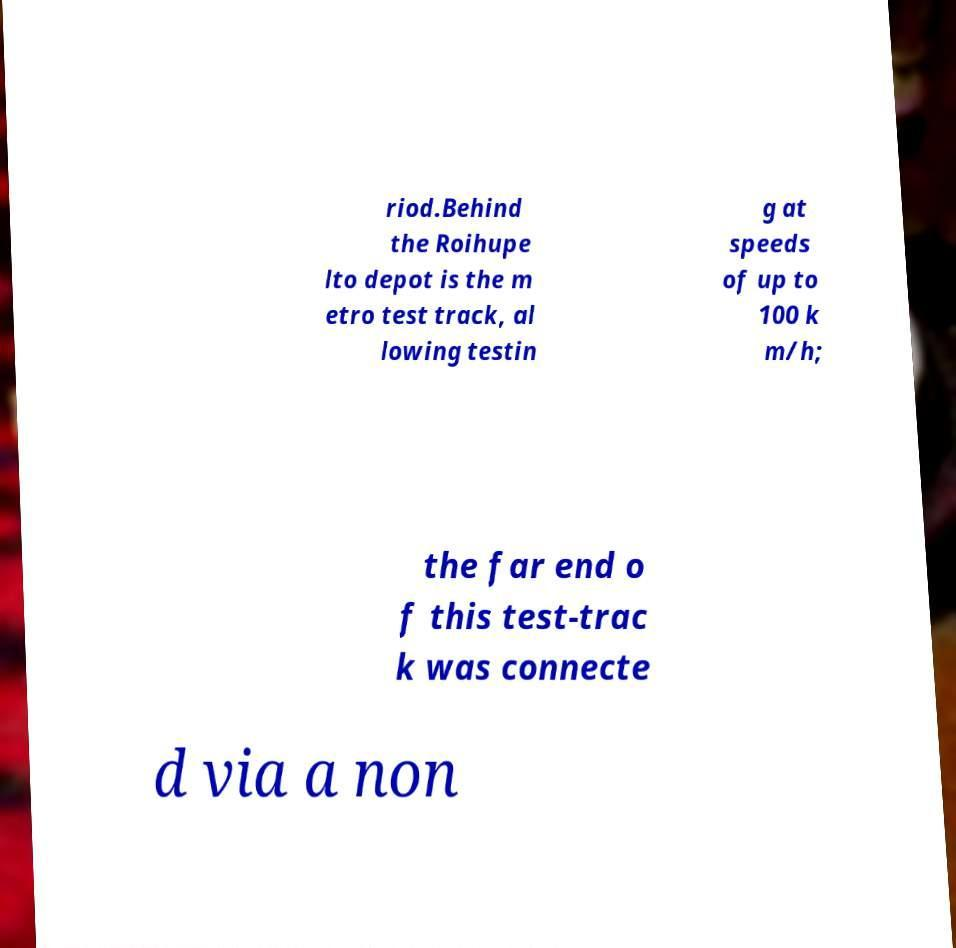I need the written content from this picture converted into text. Can you do that? riod.Behind the Roihupe lto depot is the m etro test track, al lowing testin g at speeds of up to 100 k m/h; the far end o f this test-trac k was connecte d via a non 